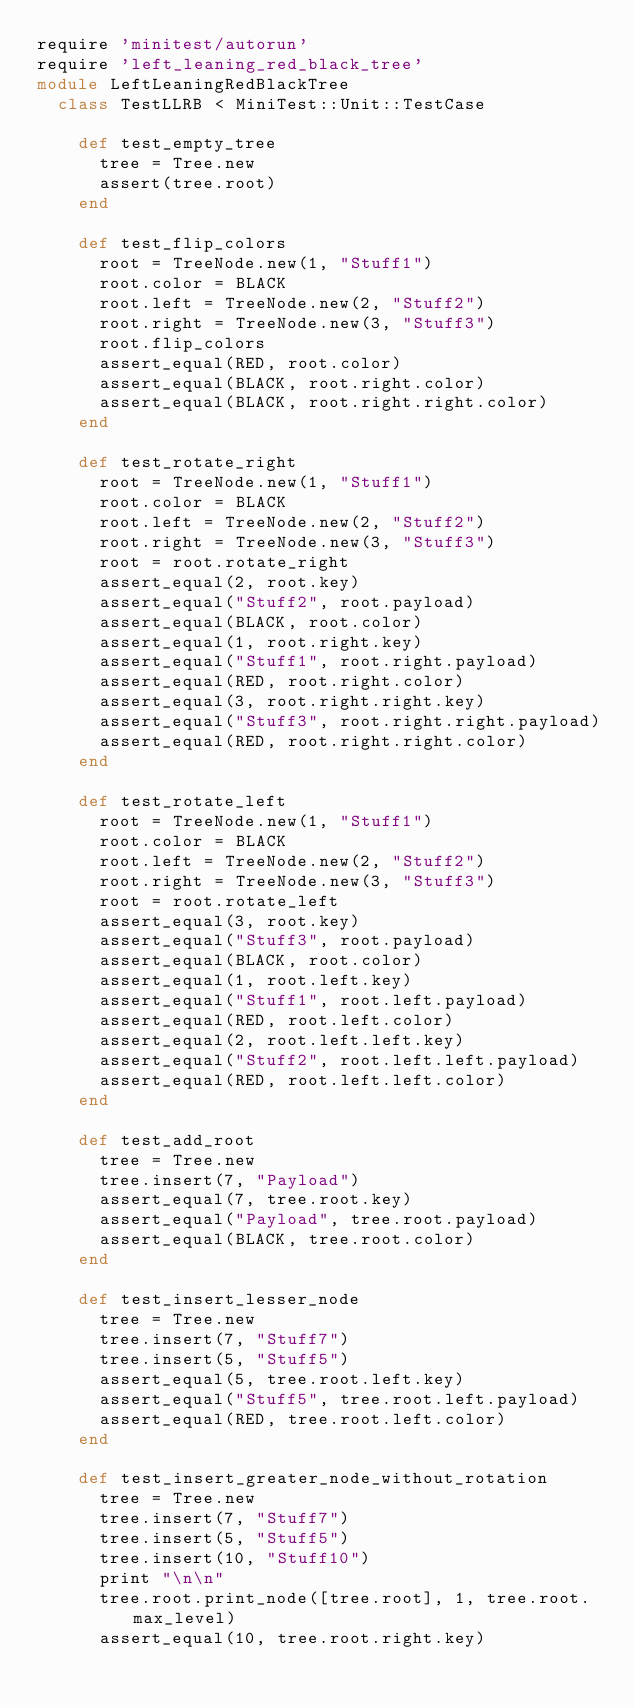<code> <loc_0><loc_0><loc_500><loc_500><_Ruby_>require 'minitest/autorun'
require 'left_leaning_red_black_tree'
module LeftLeaningRedBlackTree
  class TestLLRB < MiniTest::Unit::TestCase

    def test_empty_tree
      tree = Tree.new
      assert(tree.root)
    end

    def test_flip_colors
      root = TreeNode.new(1, "Stuff1")
      root.color = BLACK
      root.left = TreeNode.new(2, "Stuff2")
      root.right = TreeNode.new(3, "Stuff3")
      root.flip_colors
      assert_equal(RED, root.color)
      assert_equal(BLACK, root.right.color)
      assert_equal(BLACK, root.right.right.color)
    end

    def test_rotate_right
      root = TreeNode.new(1, "Stuff1")
      root.color = BLACK
      root.left = TreeNode.new(2, "Stuff2")
      root.right = TreeNode.new(3, "Stuff3")
      root = root.rotate_right
      assert_equal(2, root.key)
      assert_equal("Stuff2", root.payload)
      assert_equal(BLACK, root.color)
      assert_equal(1, root.right.key)
      assert_equal("Stuff1", root.right.payload)
      assert_equal(RED, root.right.color)
      assert_equal(3, root.right.right.key)
      assert_equal("Stuff3", root.right.right.payload)
      assert_equal(RED, root.right.right.color)
    end

    def test_rotate_left
      root = TreeNode.new(1, "Stuff1")
      root.color = BLACK
      root.left = TreeNode.new(2, "Stuff2")
      root.right = TreeNode.new(3, "Stuff3")
      root = root.rotate_left
      assert_equal(3, root.key)
      assert_equal("Stuff3", root.payload)
      assert_equal(BLACK, root.color)
      assert_equal(1, root.left.key)
      assert_equal("Stuff1", root.left.payload)
      assert_equal(RED, root.left.color)
      assert_equal(2, root.left.left.key)
      assert_equal("Stuff2", root.left.left.payload)
      assert_equal(RED, root.left.left.color)
    end

    def test_add_root
      tree = Tree.new
      tree.insert(7, "Payload")
      assert_equal(7, tree.root.key)
      assert_equal("Payload", tree.root.payload)
      assert_equal(BLACK, tree.root.color)
    end

    def test_insert_lesser_node
      tree = Tree.new
      tree.insert(7, "Stuff7")
      tree.insert(5, "Stuff5")
      assert_equal(5, tree.root.left.key)
      assert_equal("Stuff5", tree.root.left.payload)
      assert_equal(RED, tree.root.left.color)
    end

    def test_insert_greater_node_without_rotation
      tree = Tree.new
      tree.insert(7, "Stuff7")
      tree.insert(5, "Stuff5")
      tree.insert(10, "Stuff10")
      print "\n\n"
      tree.root.print_node([tree.root], 1, tree.root.max_level)
      assert_equal(10, tree.root.right.key)</code> 